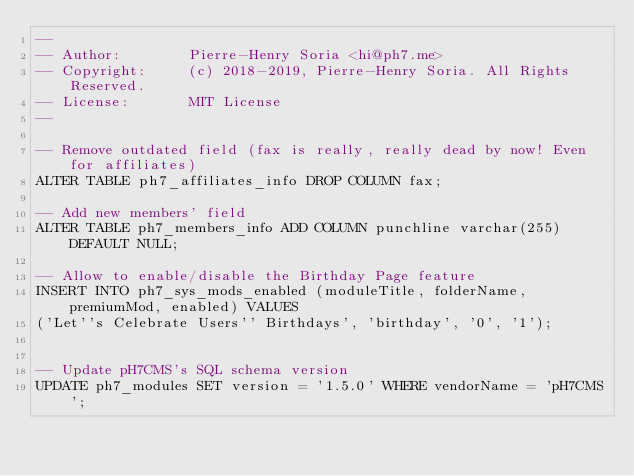<code> <loc_0><loc_0><loc_500><loc_500><_SQL_>--
-- Author:        Pierre-Henry Soria <hi@ph7.me>
-- Copyright:     (c) 2018-2019, Pierre-Henry Soria. All Rights Reserved.
-- License:       MIT License
--

-- Remove outdated field (fax is really, really dead by now! Even for affiliates)
ALTER TABLE ph7_affiliates_info DROP COLUMN fax;

-- Add new members' field
ALTER TABLE ph7_members_info ADD COLUMN punchline varchar(255) DEFAULT NULL;

-- Allow to enable/disable the Birthday Page feature
INSERT INTO ph7_sys_mods_enabled (moduleTitle, folderName, premiumMod, enabled) VALUES
('Let''s Celebrate Users'' Birthdays', 'birthday', '0', '1');


-- Update pH7CMS's SQL schema version
UPDATE ph7_modules SET version = '1.5.0' WHERE vendorName = 'pH7CMS';
</code> 